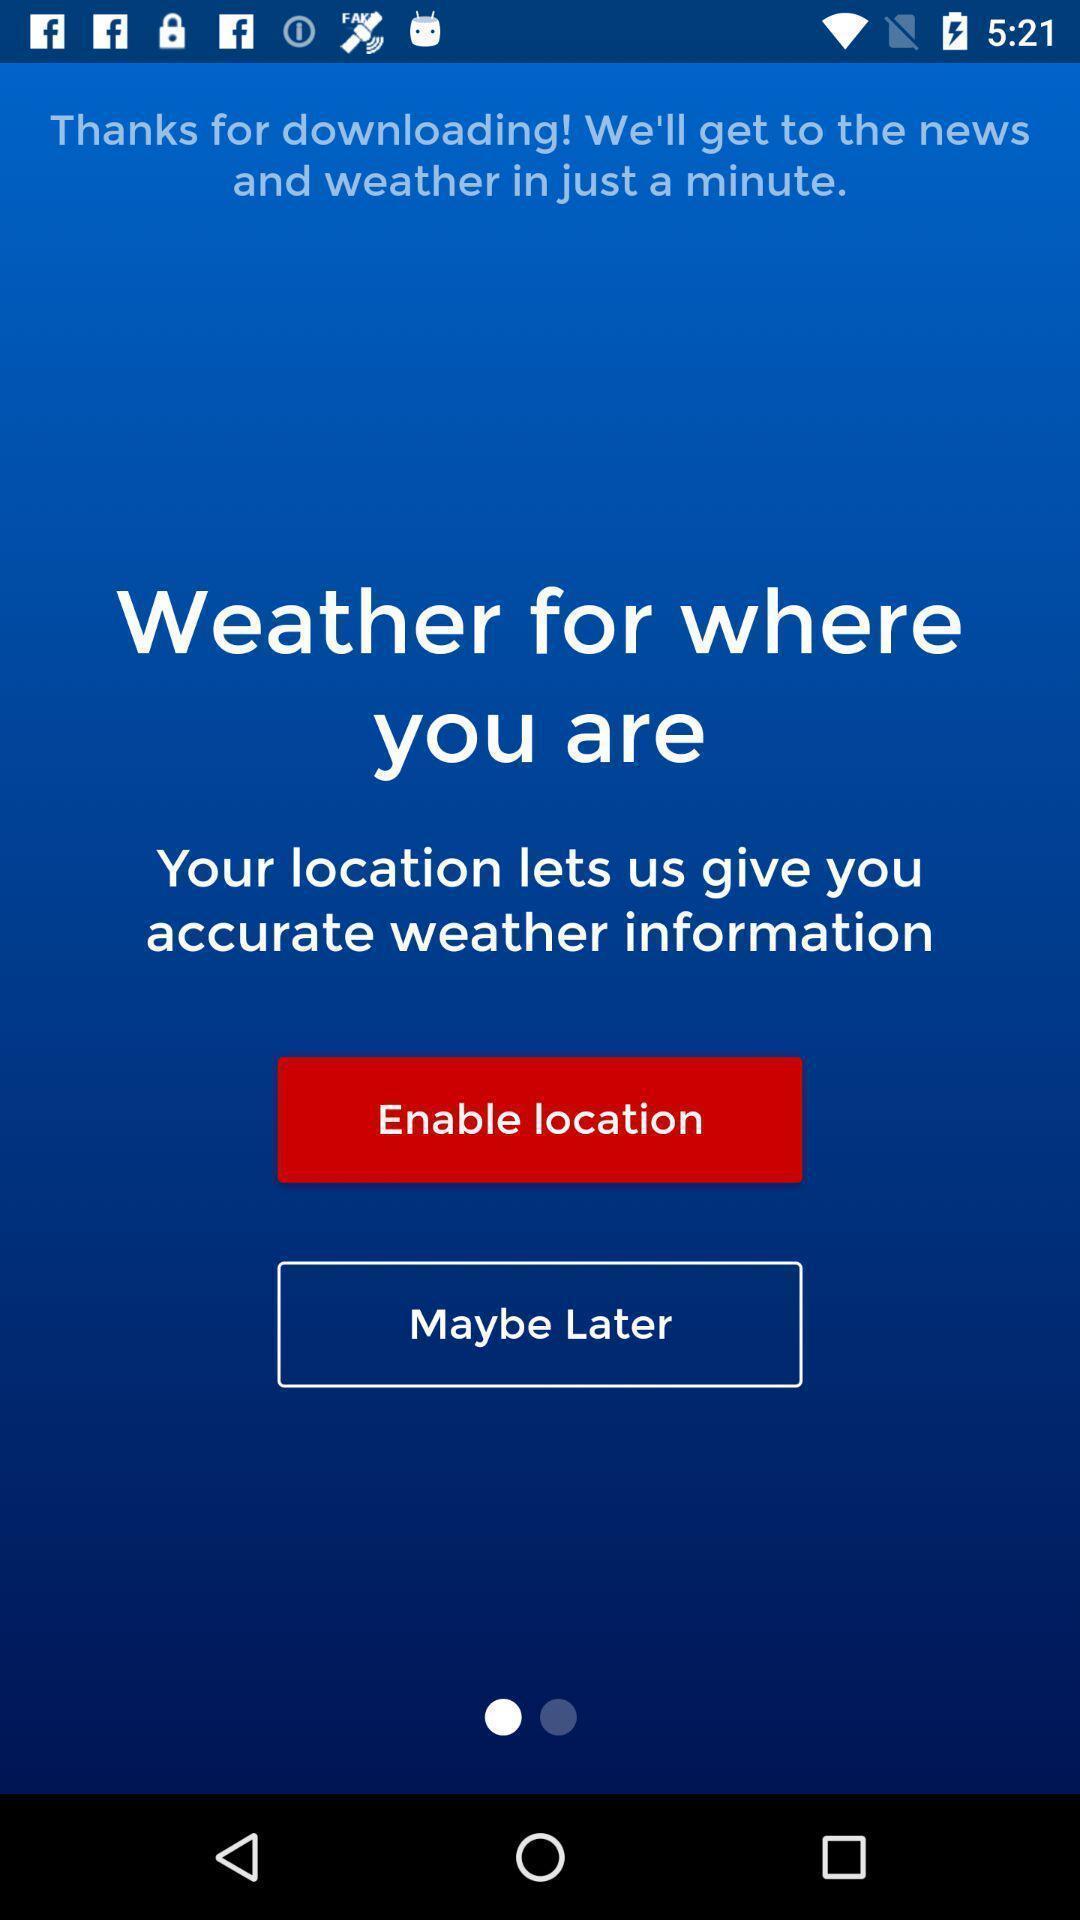Give me a summary of this screen capture. Showing the news of weather condition. 